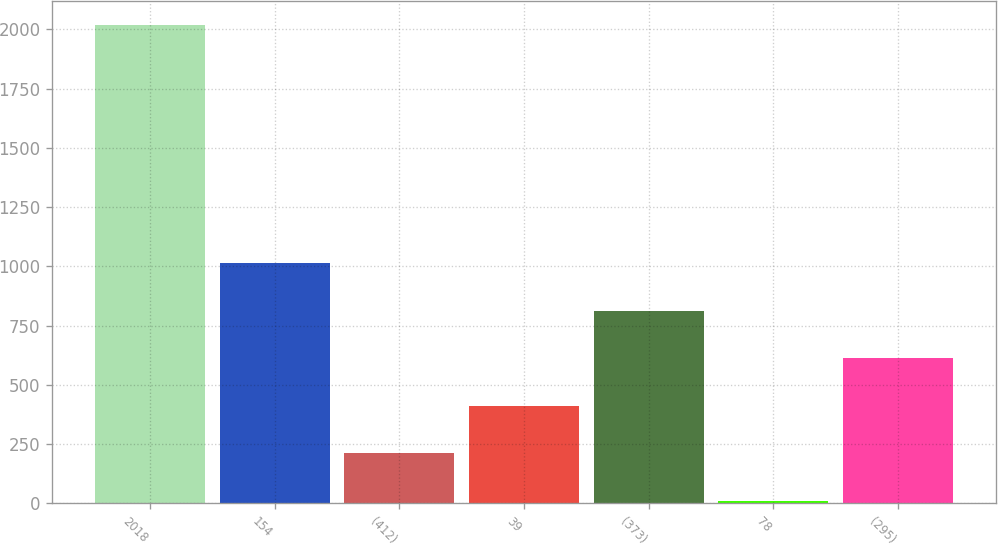Convert chart to OTSL. <chart><loc_0><loc_0><loc_500><loc_500><bar_chart><fcel>2018<fcel>154<fcel>(412)<fcel>39<fcel>(373)<fcel>78<fcel>(295)<nl><fcel>2018<fcel>1013.5<fcel>209.9<fcel>410.8<fcel>812.6<fcel>9<fcel>611.7<nl></chart> 